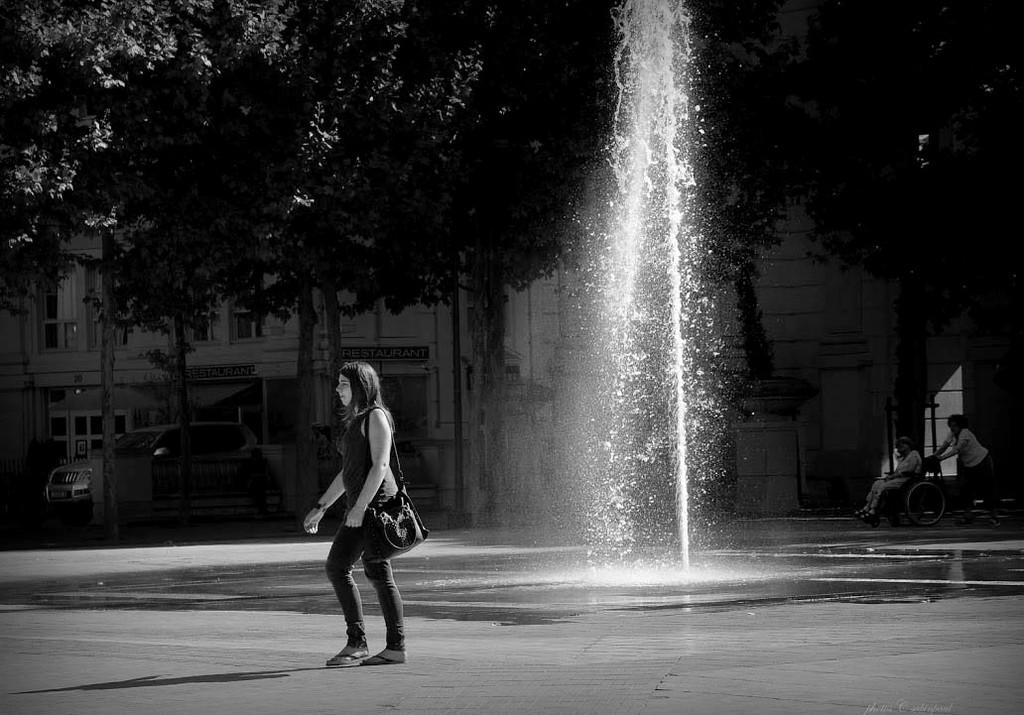Who is present in the image? There is a woman in the image. What can be seen in the image besides the woman? Water is visible in the image, and there is a vehicle and trees in the background. What type of structure can be seen in the background of the image? There is a building with text in the background of the image. What type of snake is crawling on the woman's shoulder in the image? There is no snake present in the image; the woman is not accompanied by any reptiles. 